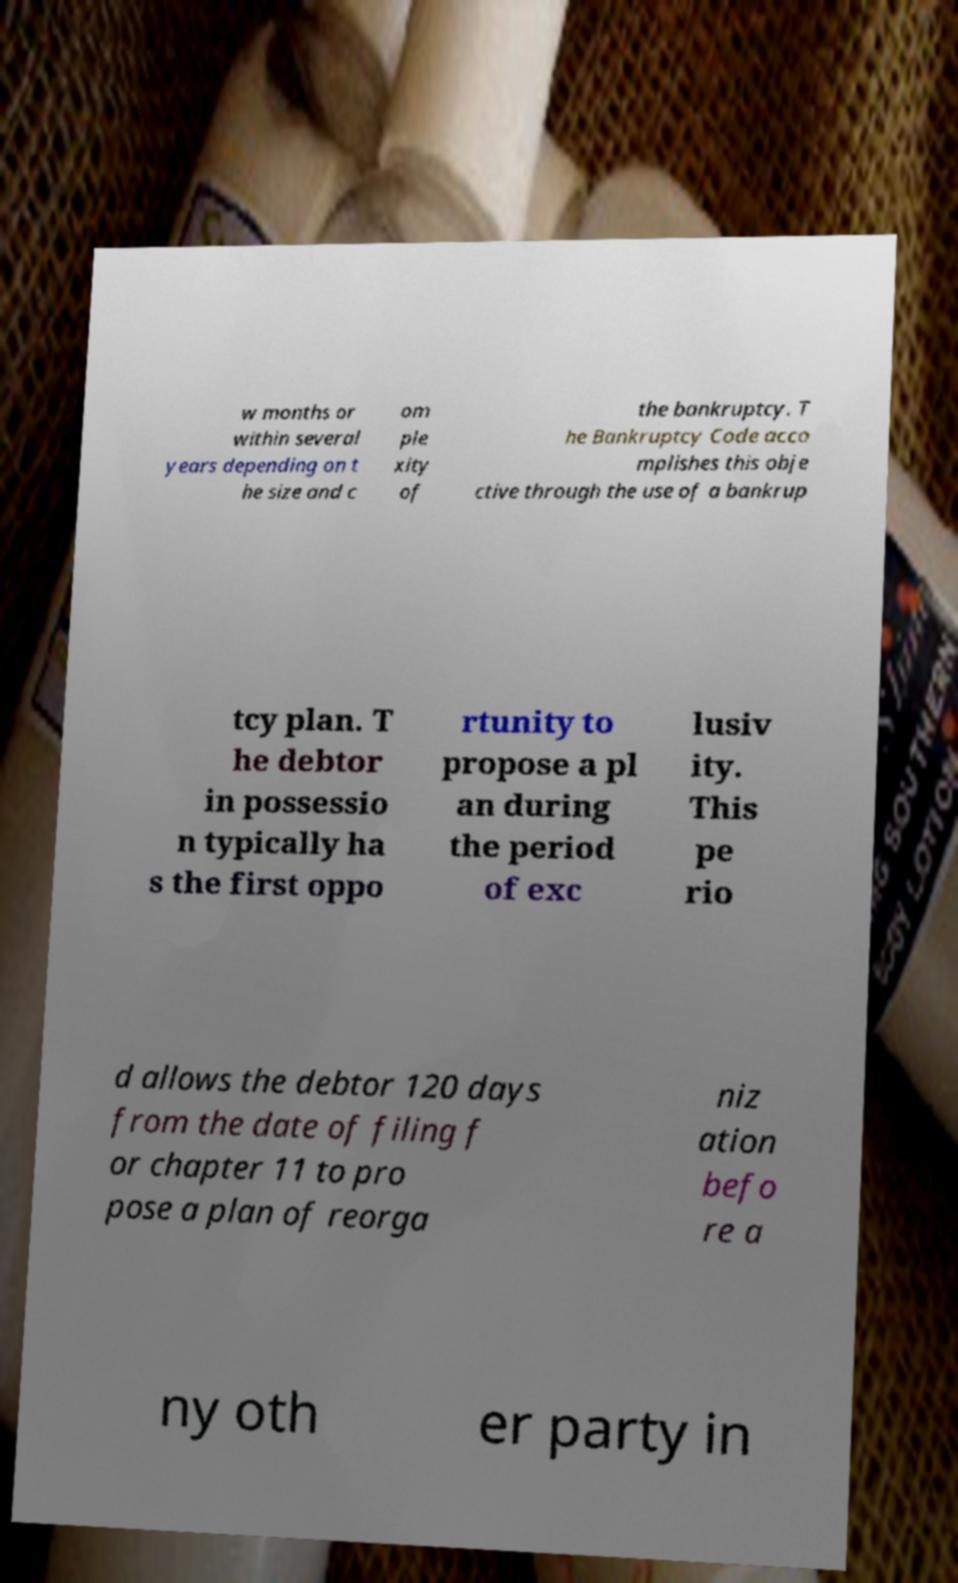Could you assist in decoding the text presented in this image and type it out clearly? w months or within several years depending on t he size and c om ple xity of the bankruptcy. T he Bankruptcy Code acco mplishes this obje ctive through the use of a bankrup tcy plan. T he debtor in possessio n typically ha s the first oppo rtunity to propose a pl an during the period of exc lusiv ity. This pe rio d allows the debtor 120 days from the date of filing f or chapter 11 to pro pose a plan of reorga niz ation befo re a ny oth er party in 